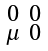Convert formula to latex. <formula><loc_0><loc_0><loc_500><loc_500>\begin{smallmatrix} 0 & 0 \\ \mu & 0 \end{smallmatrix}</formula> 